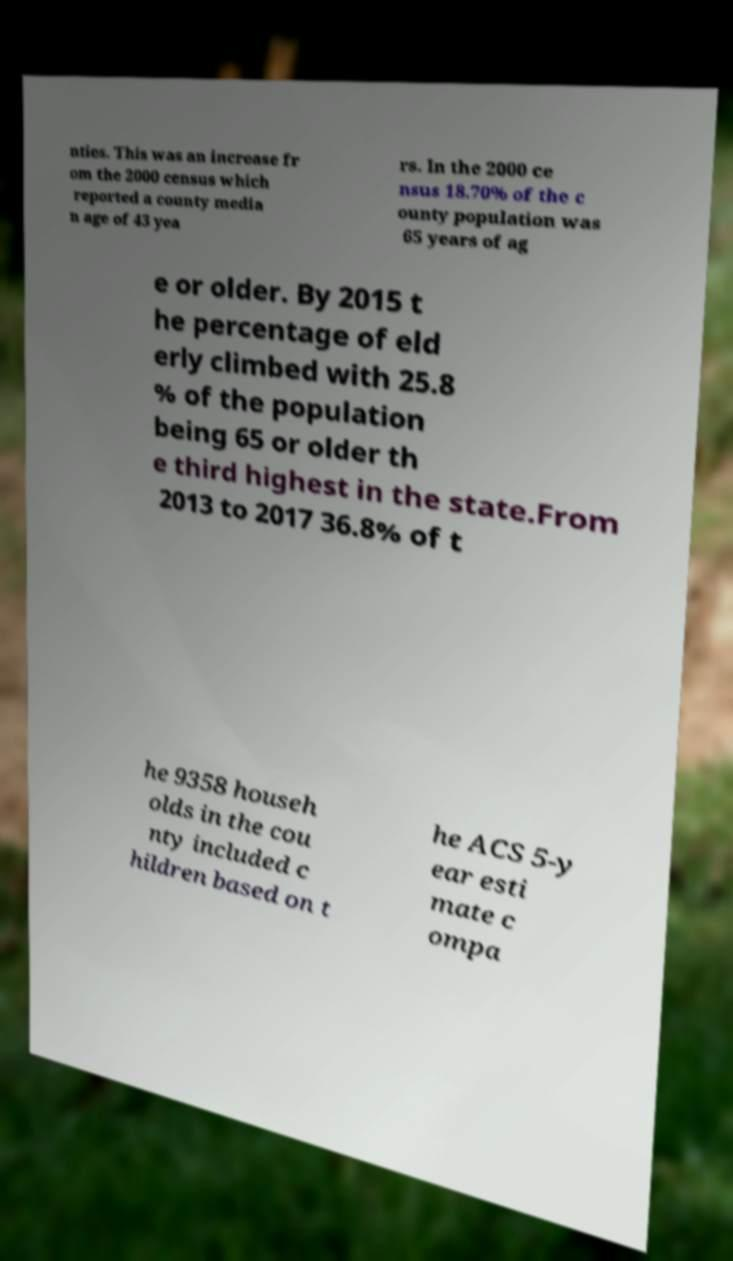I need the written content from this picture converted into text. Can you do that? nties. This was an increase fr om the 2000 census which reported a county media n age of 43 yea rs. In the 2000 ce nsus 18.70% of the c ounty population was 65 years of ag e or older. By 2015 t he percentage of eld erly climbed with 25.8 % of the population being 65 or older th e third highest in the state.From 2013 to 2017 36.8% of t he 9358 househ olds in the cou nty included c hildren based on t he ACS 5-y ear esti mate c ompa 